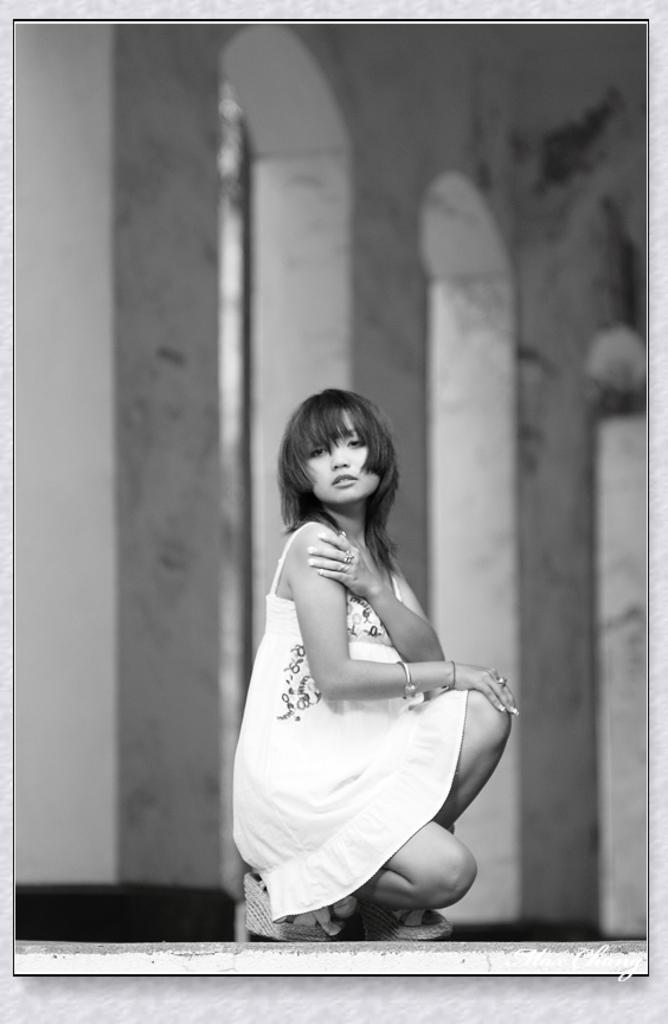Please provide a concise description of this image. In the picture we can see a woman sitting on the shoe and she is wearing a white dress and in the background we can see a building pillars. 